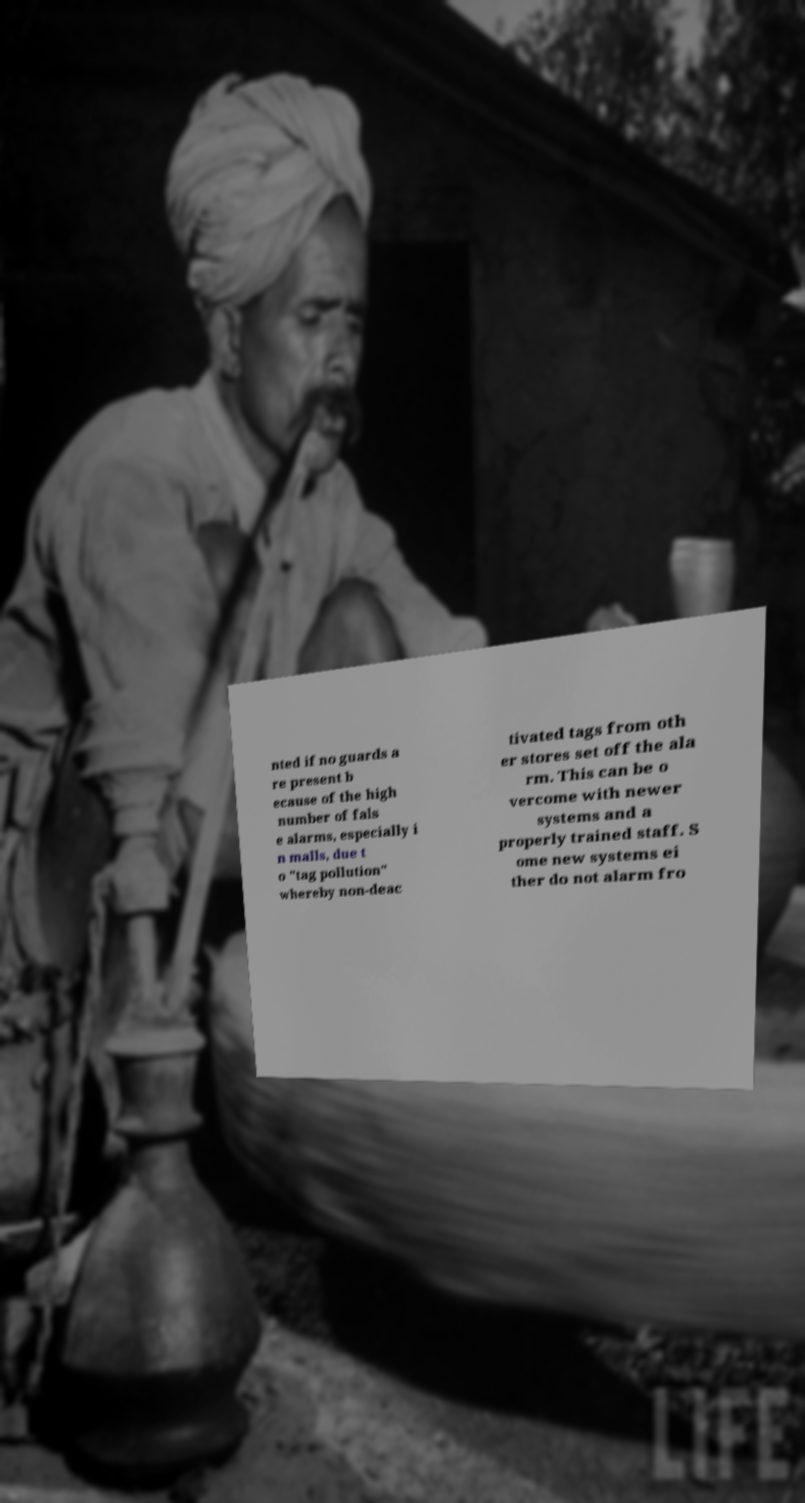For documentation purposes, I need the text within this image transcribed. Could you provide that? nted if no guards a re present b ecause of the high number of fals e alarms, especially i n malls, due t o "tag pollution" whereby non-deac tivated tags from oth er stores set off the ala rm. This can be o vercome with newer systems and a properly trained staff. S ome new systems ei ther do not alarm fro 